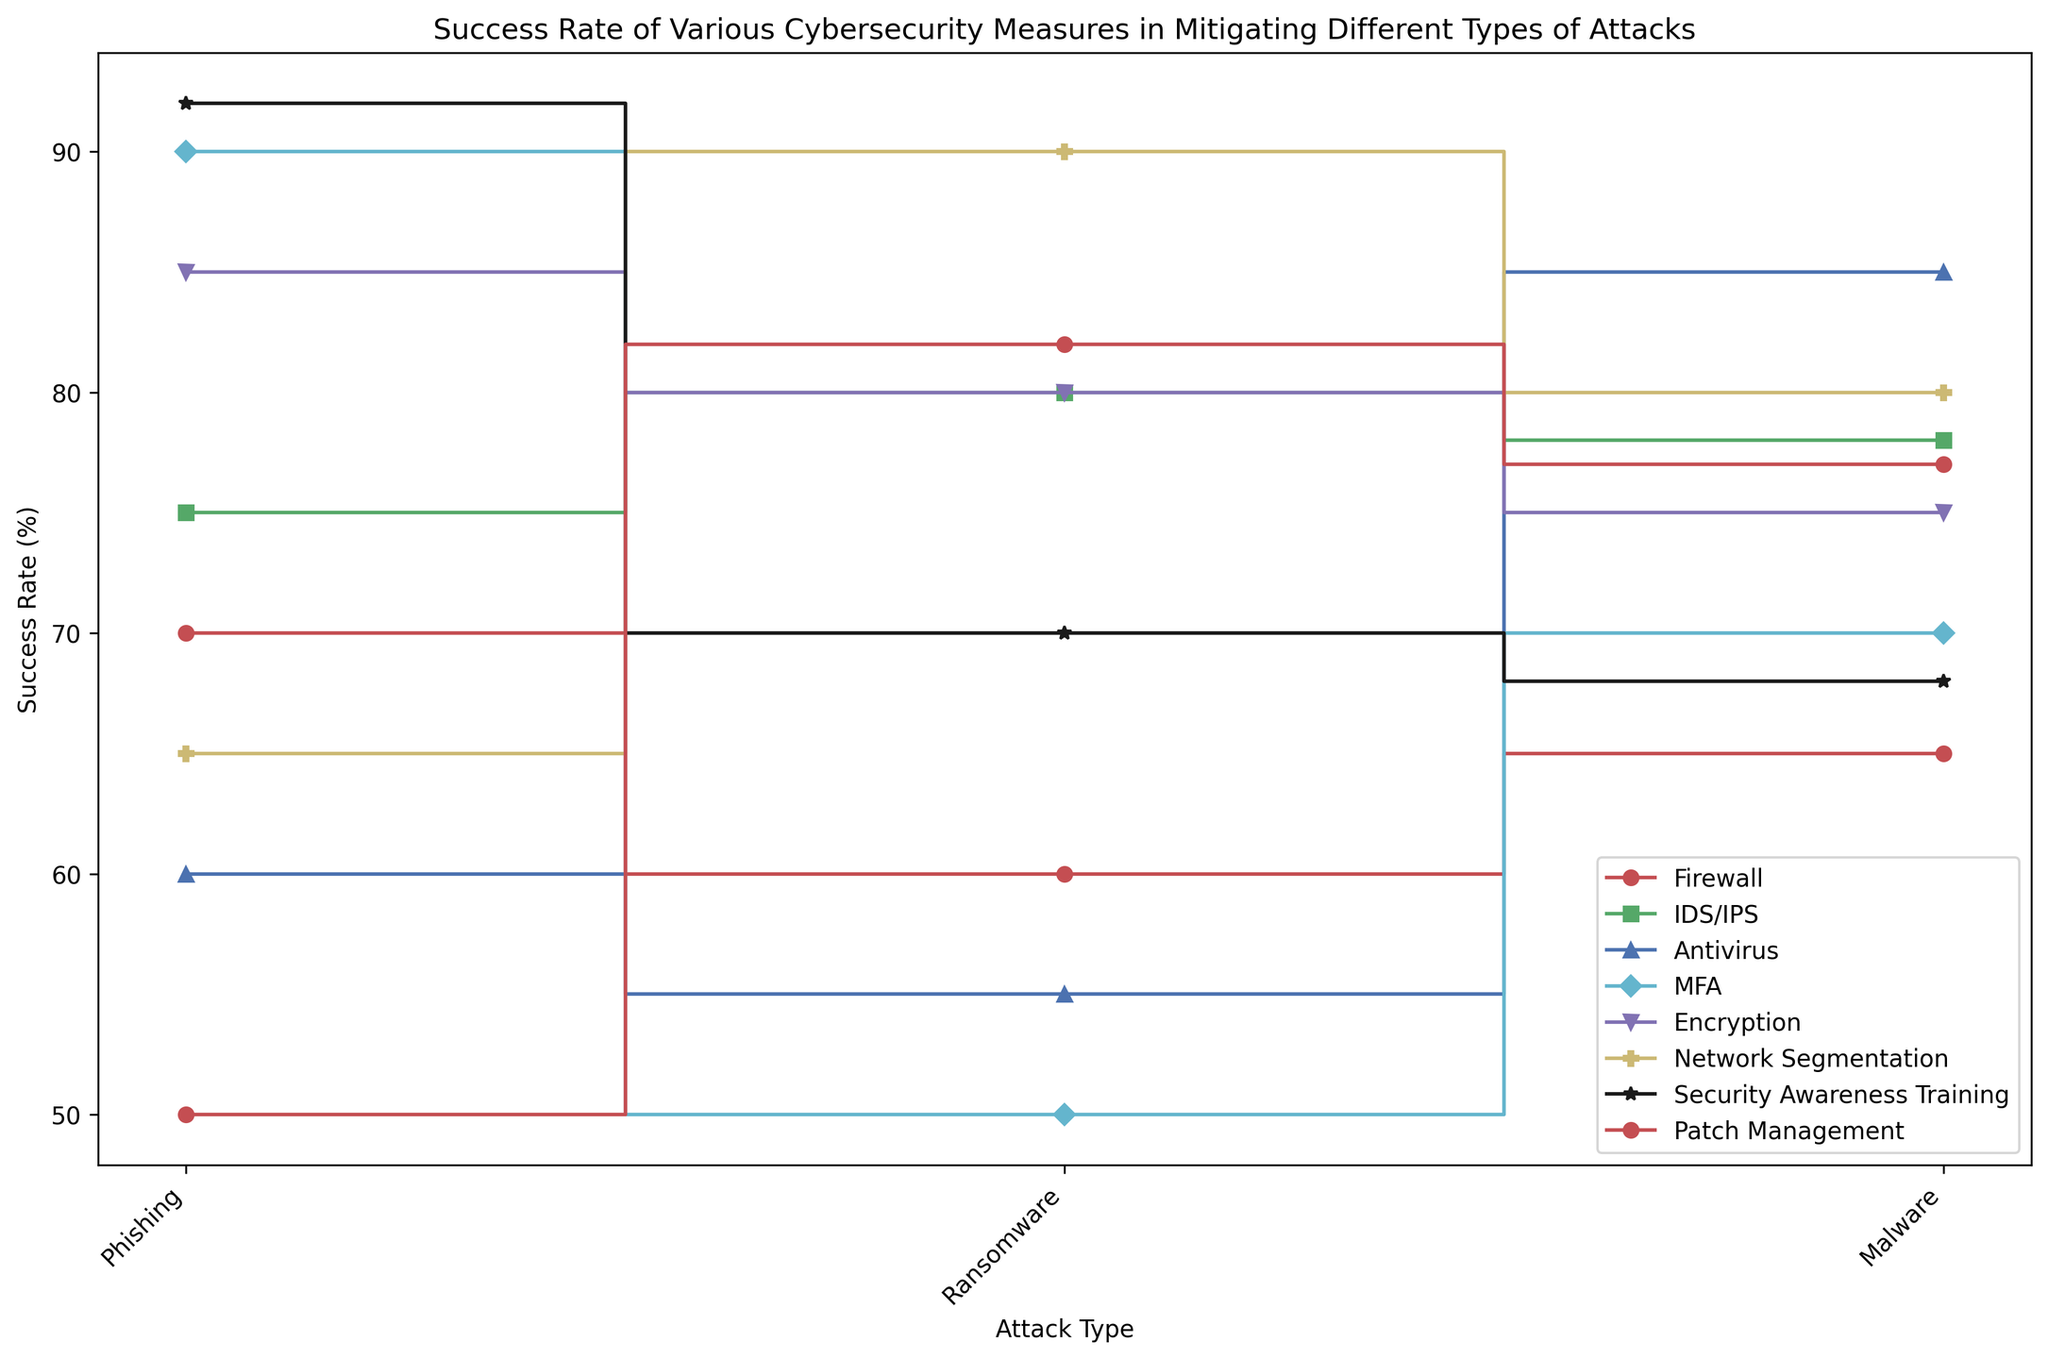What cybersecurity measure is most effective against Phishing attacks? By visually examining the plot, the highest point on the y-axis for Phishing attacks is represented by Security Awareness Training, which reaches a 92% success rate.
Answer: Security Awareness Training Among Encryption and IDS/IPS, which has a higher success rate against Ransomware? By comparing the steps for Ransomware on the plot, Encryption shows a success rate of 80%, whereas IDS/IPS has a higher success rate at 80%. Both measures have equal success rates against Ransomware.
Answer: Both have equal success rate What is the difference in success rates of MFA against Phishing and Ransomware? MFA's success rates are directly observed at 90% for Phishing and 50% for Ransomware. The difference can be calculated as 90% - 50% = 40%.
Answer: 40% Which measure is least effective against Malware attacks? By looking at the lowest step on the graph for Malware attacks, Antivirus has a success rate of 85%. However, compared to other measures, Patch Management, with a 77% success rate, is less effective.
Answer: Patch Management Calculate the average success rate of Firewall across all attack types. For Firewall, the success rates are Phishing 70%, Ransomware 60%, and Malware 65%. Average = (70 + 60 + 65) / 3 ≈ 65%.
Answer: 65% Which cybersecurity measure consistently performs above 75% success rate across all attack types? By scanning the plots of all measures for success rates, IDS/IPS consistently performs above 75% for Phishing (75%), Ransomware (80%), and Malware (78%).
Answer: IDS/IPS Which measure has the highest variation in success rates between different attacks? By observing the range within each measure's success rates, MFA has a variation from 50% (Ransomware) to 90% (Phishing), giving a range of 90% - 50% = 40%.
Answer: MFA 